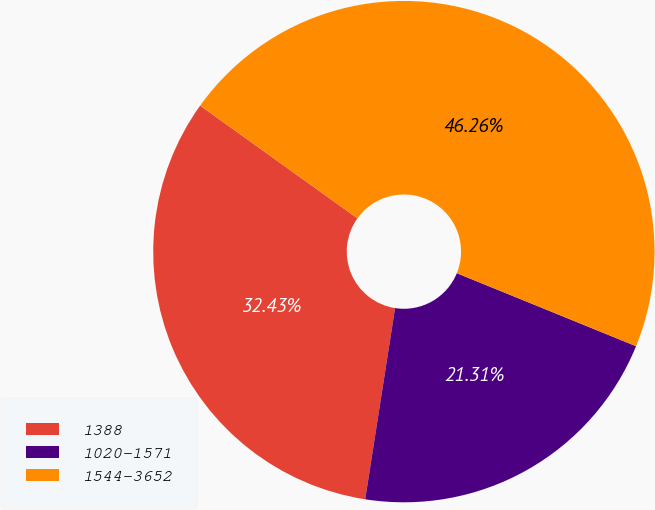Convert chart. <chart><loc_0><loc_0><loc_500><loc_500><pie_chart><fcel>1388<fcel>1020-1571<fcel>1544-3652<nl><fcel>32.43%<fcel>21.31%<fcel>46.26%<nl></chart> 